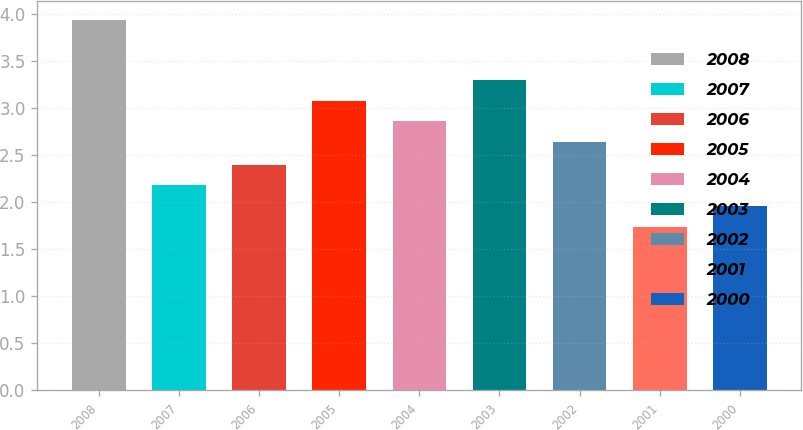Convert chart. <chart><loc_0><loc_0><loc_500><loc_500><bar_chart><fcel>2008<fcel>2007<fcel>2006<fcel>2005<fcel>2004<fcel>2003<fcel>2002<fcel>2001<fcel>2000<nl><fcel>3.94<fcel>2.18<fcel>2.4<fcel>3.08<fcel>2.86<fcel>3.3<fcel>2.64<fcel>1.74<fcel>1.96<nl></chart> 